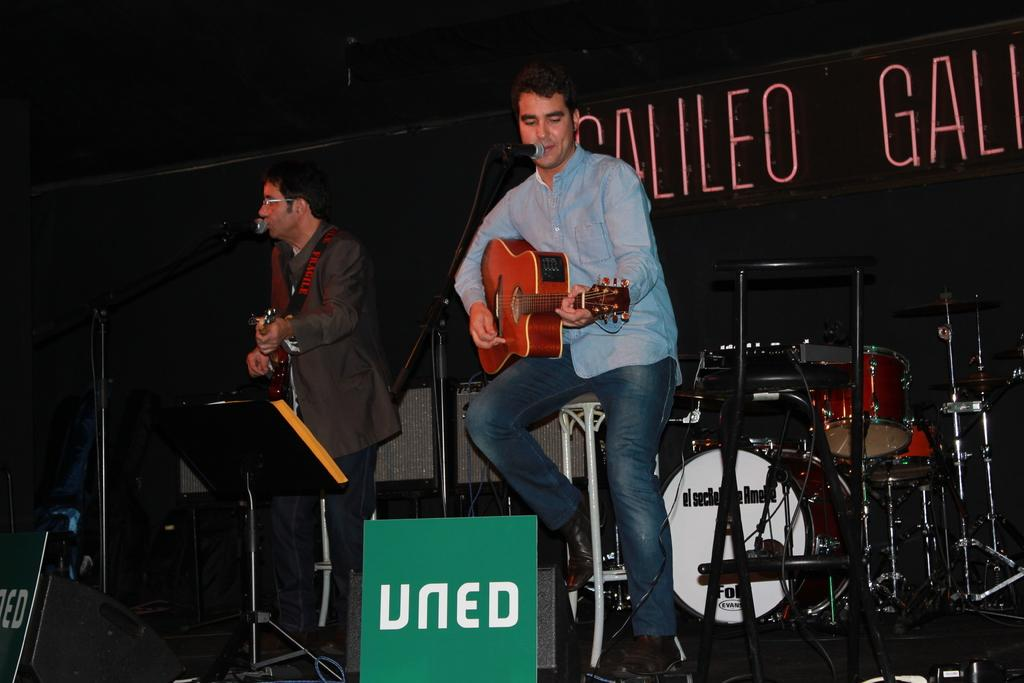How many people are in the image? There are two men in the image. What are the men doing in the image? The men are playing guitars in the image. What other objects related to music can be seen in the image? There are musical instruments and a microphone in the image. What type of bone can be seen in the image? There is no bone present in the image. Can you describe the cat in the image? There is no cat present in the image. 